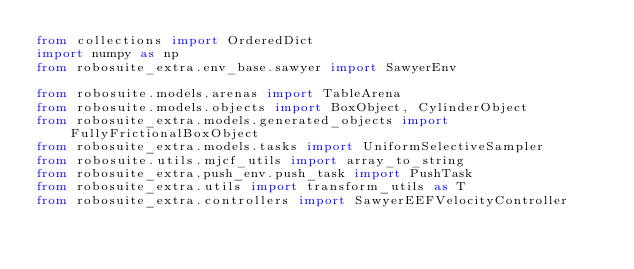<code> <loc_0><loc_0><loc_500><loc_500><_Python_>from collections import OrderedDict
import numpy as np
from robosuite_extra.env_base.sawyer import SawyerEnv

from robosuite.models.arenas import TableArena
from robosuite.models.objects import BoxObject, CylinderObject
from robosuite_extra.models.generated_objects import FullyFrictionalBoxObject
from robosuite_extra.models.tasks import UniformSelectiveSampler
from robosuite.utils.mjcf_utils import array_to_string
from robosuite_extra.push_env.push_task import PushTask
from robosuite_extra.utils import transform_utils as T
from robosuite_extra.controllers import SawyerEEFVelocityController</code> 